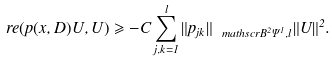Convert formula to latex. <formula><loc_0><loc_0><loc_500><loc_500>\ r e ( p ( x , D ) U , U ) \geqslant - C \sum _ { j , k = 1 } ^ { l } \| { p _ { j k } } \| _ { \ m a t h s c r { B } ^ { 2 } \Psi ^ { 1 } , l } \| { U } \| ^ { 2 } .</formula> 